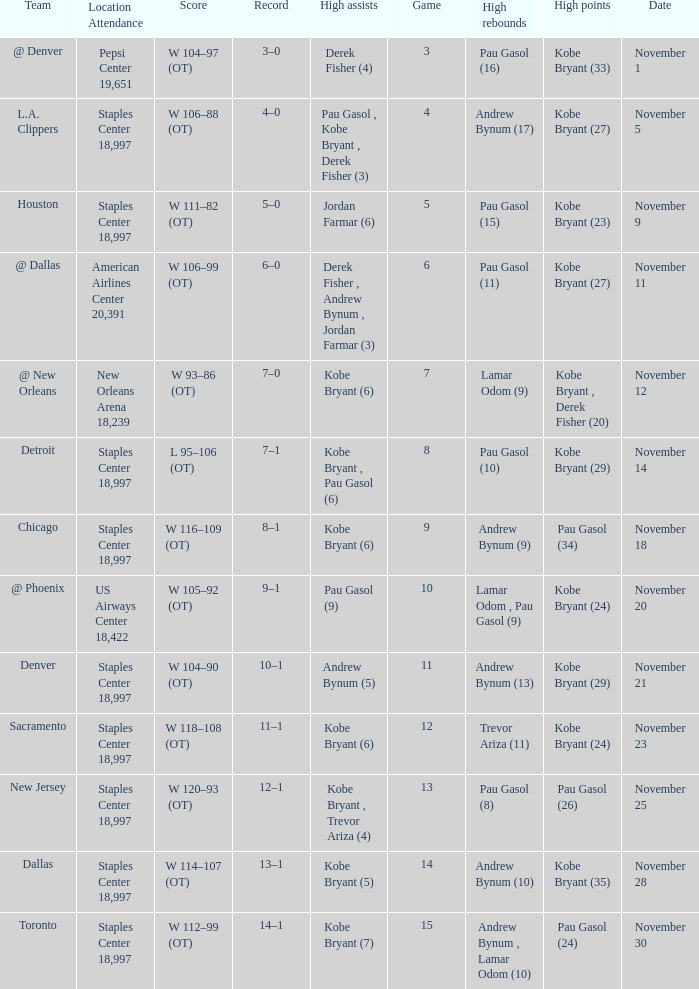I'm looking to parse the entire table for insights. Could you assist me with that? {'header': ['Team', 'Location Attendance', 'Score', 'Record', 'High assists', 'Game', 'High rebounds', 'High points', 'Date'], 'rows': [['@ Denver', 'Pepsi Center 19,651', 'W 104–97 (OT)', '3–0', 'Derek Fisher (4)', '3', 'Pau Gasol (16)', 'Kobe Bryant (33)', 'November 1'], ['L.A. Clippers', 'Staples Center 18,997', 'W 106–88 (OT)', '4–0', 'Pau Gasol , Kobe Bryant , Derek Fisher (3)', '4', 'Andrew Bynum (17)', 'Kobe Bryant (27)', 'November 5'], ['Houston', 'Staples Center 18,997', 'W 111–82 (OT)', '5–0', 'Jordan Farmar (6)', '5', 'Pau Gasol (15)', 'Kobe Bryant (23)', 'November 9'], ['@ Dallas', 'American Airlines Center 20,391', 'W 106–99 (OT)', '6–0', 'Derek Fisher , Andrew Bynum , Jordan Farmar (3)', '6', 'Pau Gasol (11)', 'Kobe Bryant (27)', 'November 11'], ['@ New Orleans', 'New Orleans Arena 18,239', 'W 93–86 (OT)', '7–0', 'Kobe Bryant (6)', '7', 'Lamar Odom (9)', 'Kobe Bryant , Derek Fisher (20)', 'November 12'], ['Detroit', 'Staples Center 18,997', 'L 95–106 (OT)', '7–1', 'Kobe Bryant , Pau Gasol (6)', '8', 'Pau Gasol (10)', 'Kobe Bryant (29)', 'November 14'], ['Chicago', 'Staples Center 18,997', 'W 116–109 (OT)', '8–1', 'Kobe Bryant (6)', '9', 'Andrew Bynum (9)', 'Pau Gasol (34)', 'November 18'], ['@ Phoenix', 'US Airways Center 18,422', 'W 105–92 (OT)', '9–1', 'Pau Gasol (9)', '10', 'Lamar Odom , Pau Gasol (9)', 'Kobe Bryant (24)', 'November 20'], ['Denver', 'Staples Center 18,997', 'W 104–90 (OT)', '10–1', 'Andrew Bynum (5)', '11', 'Andrew Bynum (13)', 'Kobe Bryant (29)', 'November 21'], ['Sacramento', 'Staples Center 18,997', 'W 118–108 (OT)', '11–1', 'Kobe Bryant (6)', '12', 'Trevor Ariza (11)', 'Kobe Bryant (24)', 'November 23'], ['New Jersey', 'Staples Center 18,997', 'W 120–93 (OT)', '12–1', 'Kobe Bryant , Trevor Ariza (4)', '13', 'Pau Gasol (8)', 'Pau Gasol (26)', 'November 25'], ['Dallas', 'Staples Center 18,997', 'W 114–107 (OT)', '13–1', 'Kobe Bryant (5)', '14', 'Andrew Bynum (10)', 'Kobe Bryant (35)', 'November 28'], ['Toronto', 'Staples Center 18,997', 'W 112–99 (OT)', '14–1', 'Kobe Bryant (7)', '15', 'Andrew Bynum , Lamar Odom (10)', 'Pau Gasol (24)', 'November 30']]} What is High Assists, when High Points is "Kobe Bryant (27)", and when High Rebounds is "Pau Gasol (11)"? Derek Fisher , Andrew Bynum , Jordan Farmar (3). 